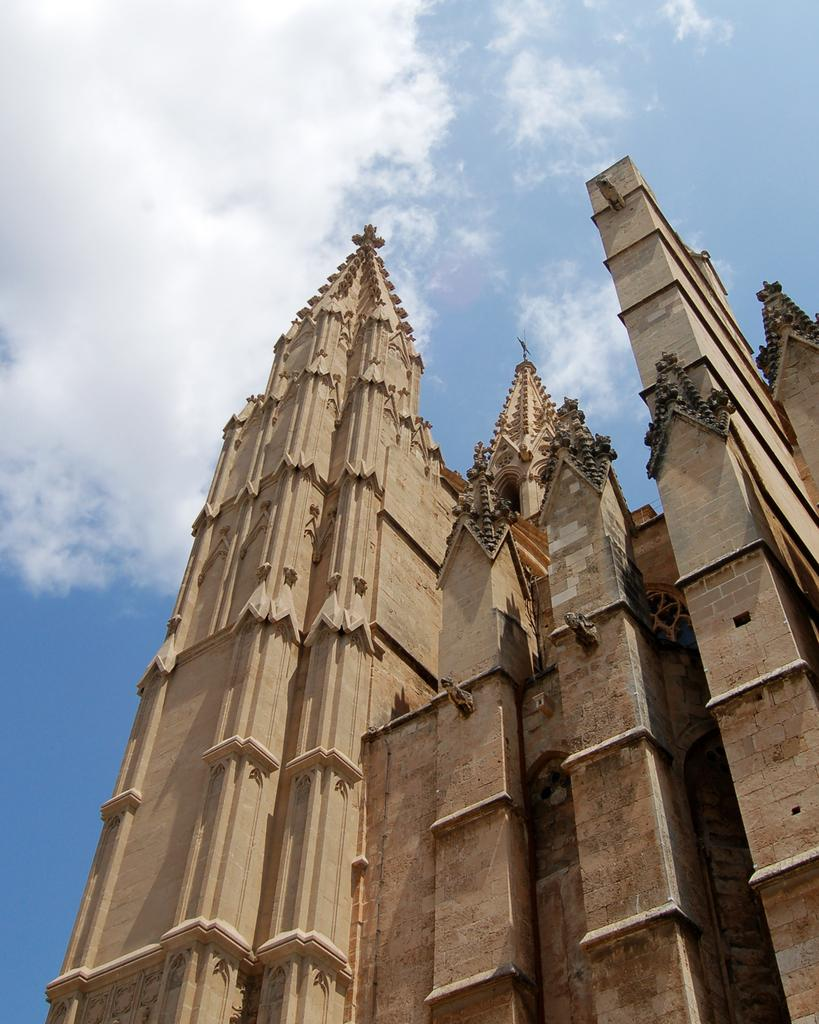What is the main subject of the picture? The main subject of the picture is a building. What can be seen in the background of the picture? The sky is visible in the background of the picture. Where are the chickens playing during recess in the image? There are no chickens or recess present in the image; it features a building and the sky. 